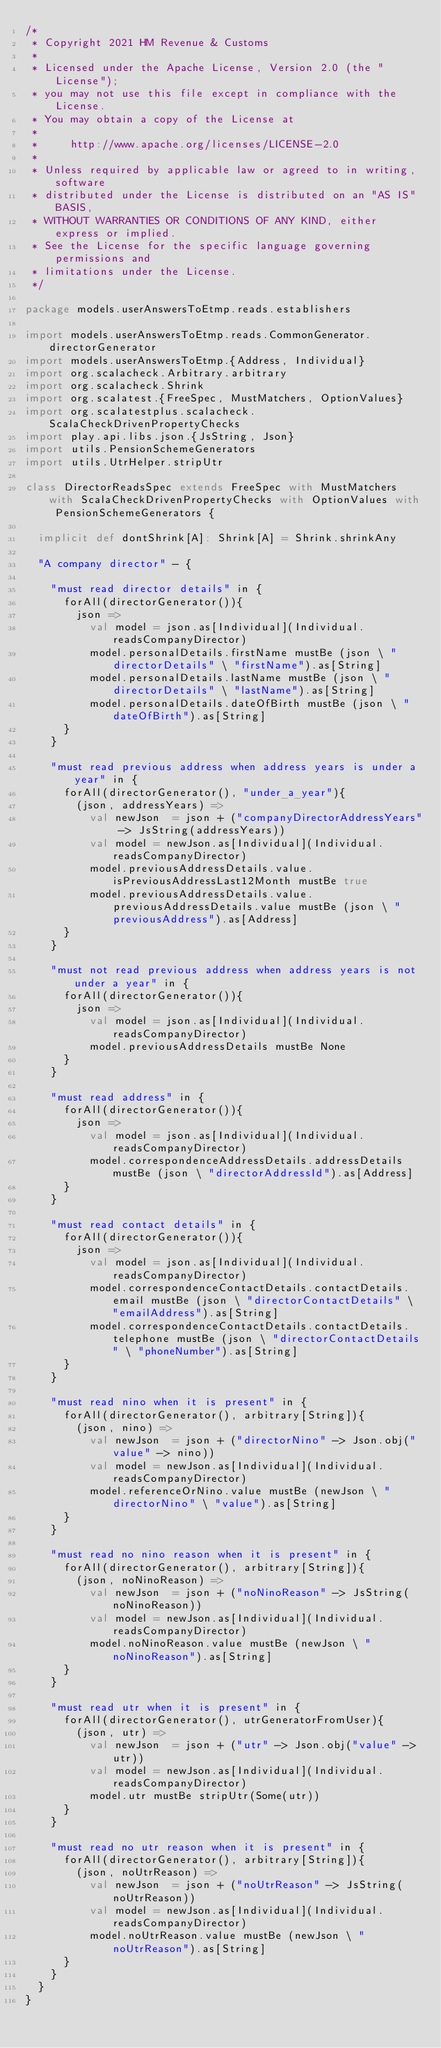Convert code to text. <code><loc_0><loc_0><loc_500><loc_500><_Scala_>/*
 * Copyright 2021 HM Revenue & Customs
 *
 * Licensed under the Apache License, Version 2.0 (the "License");
 * you may not use this file except in compliance with the License.
 * You may obtain a copy of the License at
 *
 *     http://www.apache.org/licenses/LICENSE-2.0
 *
 * Unless required by applicable law or agreed to in writing, software
 * distributed under the License is distributed on an "AS IS" BASIS,
 * WITHOUT WARRANTIES OR CONDITIONS OF ANY KIND, either express or implied.
 * See the License for the specific language governing permissions and
 * limitations under the License.
 */

package models.userAnswersToEtmp.reads.establishers

import models.userAnswersToEtmp.reads.CommonGenerator.directorGenerator
import models.userAnswersToEtmp.{Address, Individual}
import org.scalacheck.Arbitrary.arbitrary
import org.scalacheck.Shrink
import org.scalatest.{FreeSpec, MustMatchers, OptionValues}
import org.scalatestplus.scalacheck.ScalaCheckDrivenPropertyChecks
import play.api.libs.json.{JsString, Json}
import utils.PensionSchemeGenerators
import utils.UtrHelper.stripUtr

class DirectorReadsSpec extends FreeSpec with MustMatchers with ScalaCheckDrivenPropertyChecks with OptionValues with PensionSchemeGenerators {

  implicit def dontShrink[A]: Shrink[A] = Shrink.shrinkAny

  "A company director" - {

    "must read director details" in {
      forAll(directorGenerator()){
        json =>
          val model = json.as[Individual](Individual.readsCompanyDirector)
          model.personalDetails.firstName mustBe (json \ "directorDetails" \ "firstName").as[String]
          model.personalDetails.lastName mustBe (json \ "directorDetails" \ "lastName").as[String]
          model.personalDetails.dateOfBirth mustBe (json \ "dateOfBirth").as[String]
      }
    }

    "must read previous address when address years is under a year" in {
      forAll(directorGenerator(), "under_a_year"){
        (json, addressYears) =>
          val newJson  = json + ("companyDirectorAddressYears" -> JsString(addressYears))
          val model = newJson.as[Individual](Individual.readsCompanyDirector)
          model.previousAddressDetails.value.isPreviousAddressLast12Month mustBe true
          model.previousAddressDetails.value.previousAddressDetails.value mustBe (json \ "previousAddress").as[Address]
      }
    }

    "must not read previous address when address years is not under a year" in {
      forAll(directorGenerator()){
        json =>
          val model = json.as[Individual](Individual.readsCompanyDirector)
          model.previousAddressDetails mustBe None
      }
    }

    "must read address" in {
      forAll(directorGenerator()){
        json =>
          val model = json.as[Individual](Individual.readsCompanyDirector)
          model.correspondenceAddressDetails.addressDetails mustBe (json \ "directorAddressId").as[Address]
      }
    }

    "must read contact details" in {
      forAll(directorGenerator()){
        json =>
          val model = json.as[Individual](Individual.readsCompanyDirector)
          model.correspondenceContactDetails.contactDetails.email mustBe (json \ "directorContactDetails" \ "emailAddress").as[String]
          model.correspondenceContactDetails.contactDetails.telephone mustBe (json \ "directorContactDetails" \ "phoneNumber").as[String]
      }
    }

    "must read nino when it is present" in {
      forAll(directorGenerator(), arbitrary[String]){
        (json, nino) =>
          val newJson  = json + ("directorNino" -> Json.obj("value" -> nino))
          val model = newJson.as[Individual](Individual.readsCompanyDirector)
          model.referenceOrNino.value mustBe (newJson \ "directorNino" \ "value").as[String]
      }
    }

    "must read no nino reason when it is present" in {
      forAll(directorGenerator(), arbitrary[String]){
        (json, noNinoReason) =>
          val newJson  = json + ("noNinoReason" -> JsString(noNinoReason))
          val model = newJson.as[Individual](Individual.readsCompanyDirector)
          model.noNinoReason.value mustBe (newJson \ "noNinoReason").as[String]
      }
    }

    "must read utr when it is present" in {
      forAll(directorGenerator(), utrGeneratorFromUser){
        (json, utr) =>
          val newJson  = json + ("utr" -> Json.obj("value" -> utr))
          val model = newJson.as[Individual](Individual.readsCompanyDirector)
          model.utr mustBe stripUtr(Some(utr))
      }
    }

    "must read no utr reason when it is present" in {
      forAll(directorGenerator(), arbitrary[String]){
        (json, noUtrReason) =>
          val newJson  = json + ("noUtrReason" -> JsString(noUtrReason))
          val model = newJson.as[Individual](Individual.readsCompanyDirector)
          model.noUtrReason.value mustBe (newJson \ "noUtrReason").as[String]
      }
    }
  }
}
</code> 